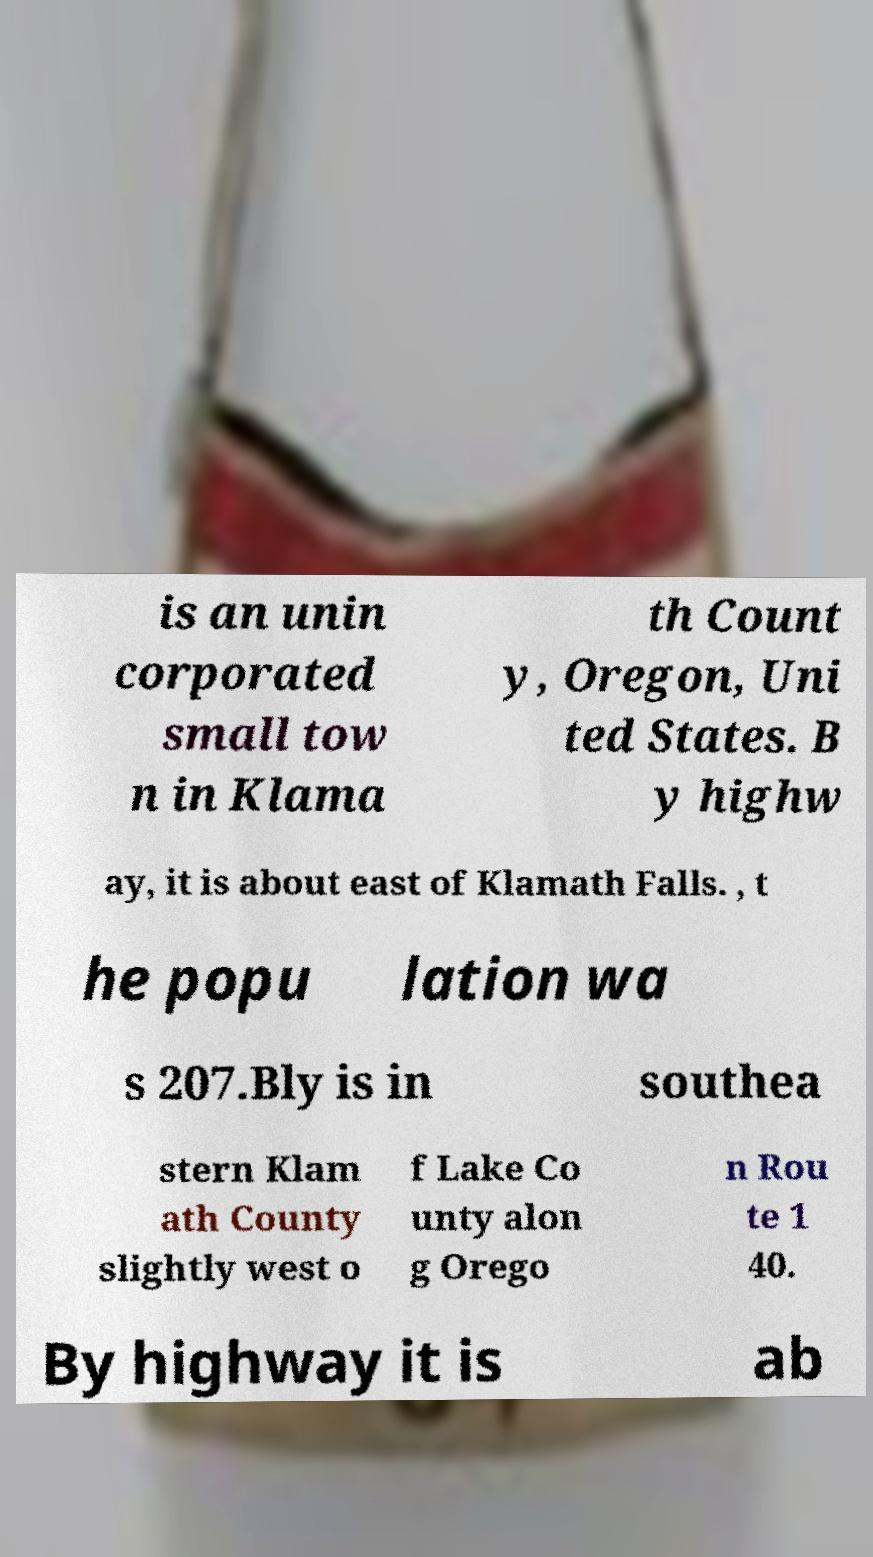Can you accurately transcribe the text from the provided image for me? is an unin corporated small tow n in Klama th Count y, Oregon, Uni ted States. B y highw ay, it is about east of Klamath Falls. , t he popu lation wa s 207.Bly is in southea stern Klam ath County slightly west o f Lake Co unty alon g Orego n Rou te 1 40. By highway it is ab 